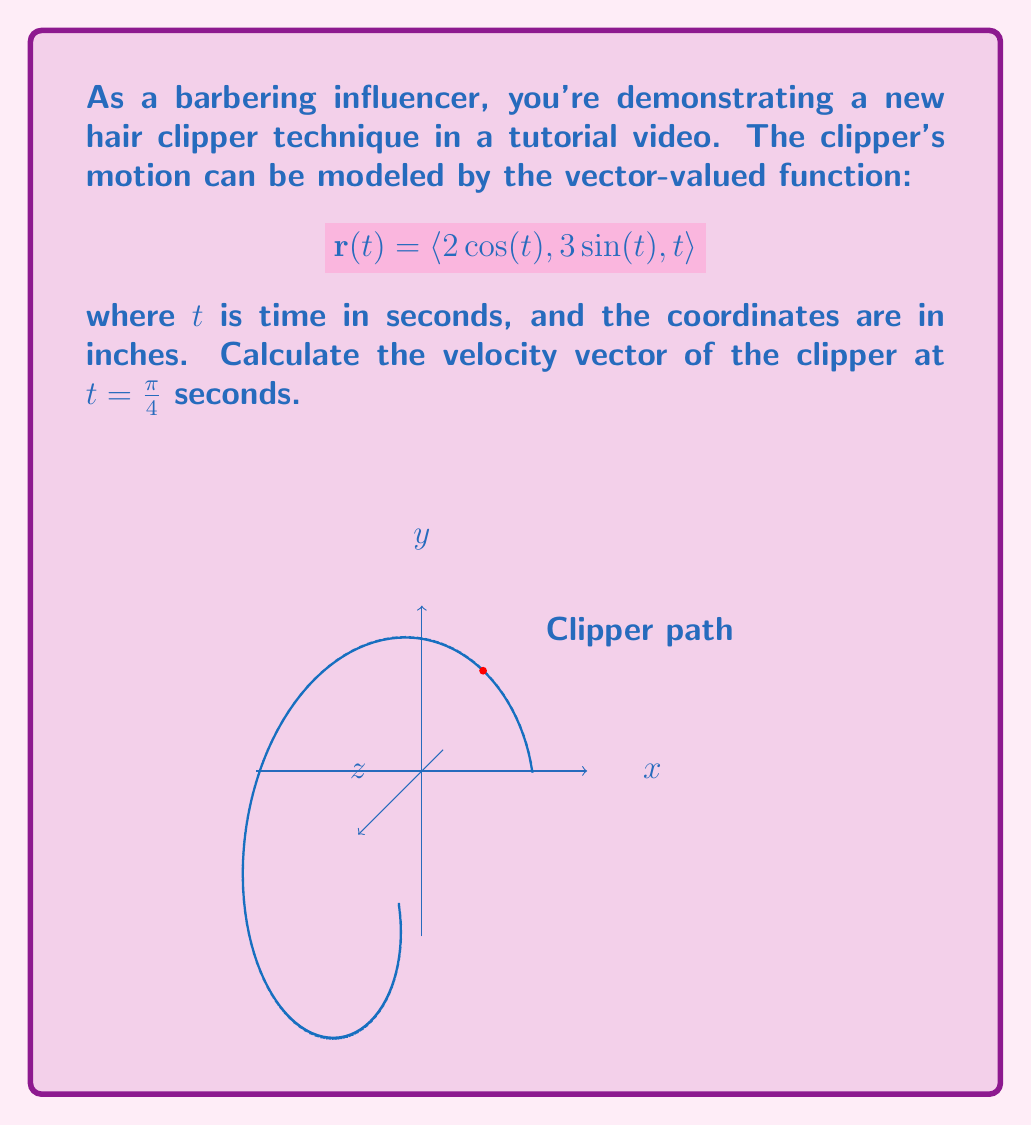Could you help me with this problem? To find the velocity vector, we need to differentiate the position vector $\mathbf{r}(t)$ with respect to time:

1) The velocity vector is given by $\mathbf{v}(t) = \mathbf{r}'(t)$

2) Differentiate each component:
   $$\begin{aligned}
   x'(t) &= -2\sin(t) \\
   y'(t) &= 3\cos(t) \\
   z'(t) &= 1
   \end{aligned}$$

3) Therefore, $\mathbf{v}(t) = \langle -2\sin(t), 3\cos(t), 1 \rangle$

4) Evaluate at $t = \frac{\pi}{4}$:
   $$\begin{aligned}
   \mathbf{v}(\frac{\pi}{4}) &= \left\langle -2\sin(\frac{\pi}{4}), 3\cos(\frac{\pi}{4}), 1 \right\rangle \\
   &= \left\langle -2 \cdot \frac{\sqrt{2}}{2}, 3 \cdot \frac{\sqrt{2}}{2}, 1 \right\rangle \\
   &= \left\langle -\sqrt{2}, \frac{3\sqrt{2}}{2}, 1 \right\rangle
   \end{aligned}$$

Thus, the velocity vector at $t = \frac{\pi}{4}$ seconds is $\left\langle -\sqrt{2}, \frac{3\sqrt{2}}{2}, 1 \right\rangle$ inches per second.
Answer: $\left\langle -\sqrt{2}, \frac{3\sqrt{2}}{2}, 1 \right\rangle$ in/s 